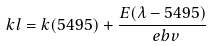Convert formula to latex. <formula><loc_0><loc_0><loc_500><loc_500>\ k l = k ( 5 4 9 5 ) + \frac { E ( \lambda - 5 4 9 5 ) } { \ e b v }</formula> 